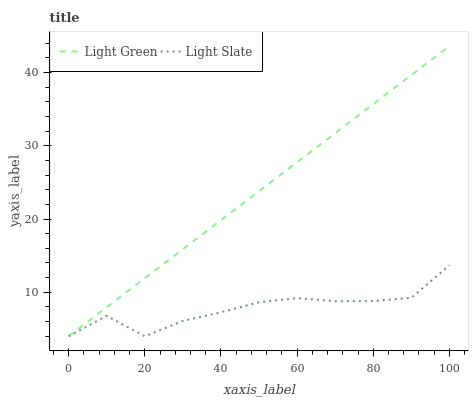Does Light Slate have the minimum area under the curve?
Answer yes or no. Yes. Does Light Green have the maximum area under the curve?
Answer yes or no. Yes. Does Light Green have the minimum area under the curve?
Answer yes or no. No. Is Light Green the smoothest?
Answer yes or no. Yes. Is Light Slate the roughest?
Answer yes or no. Yes. Is Light Green the roughest?
Answer yes or no. No. Does Light Slate have the lowest value?
Answer yes or no. Yes. Does Light Green have the highest value?
Answer yes or no. Yes. Does Light Green intersect Light Slate?
Answer yes or no. Yes. Is Light Green less than Light Slate?
Answer yes or no. No. Is Light Green greater than Light Slate?
Answer yes or no. No. 